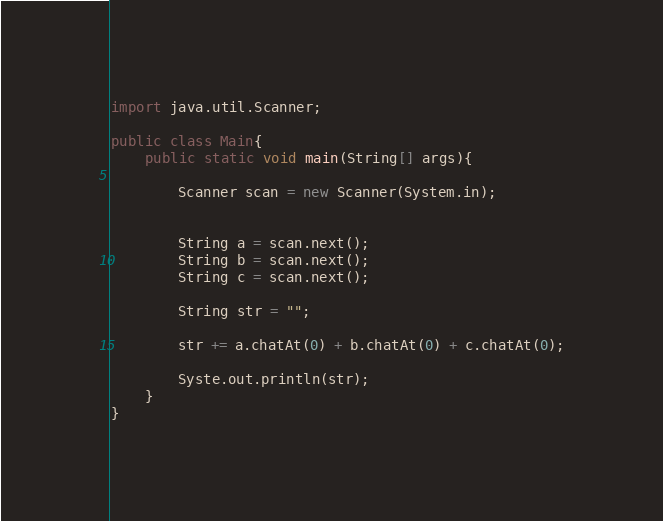Convert code to text. <code><loc_0><loc_0><loc_500><loc_500><_Java_>import java.util.Scanner;

public class Main{
	public static void main(String[] args){
		
		Scanner scan = new Scanner(System.in);


		String a = scan.next();
		String b = scan.next();
		String c = scan.next();

		String str = "";

		str += a.chatAt(0) + b.chatAt(0) + c.chatAt(0);

		Syste.out.println(str);
	}
}
</code> 